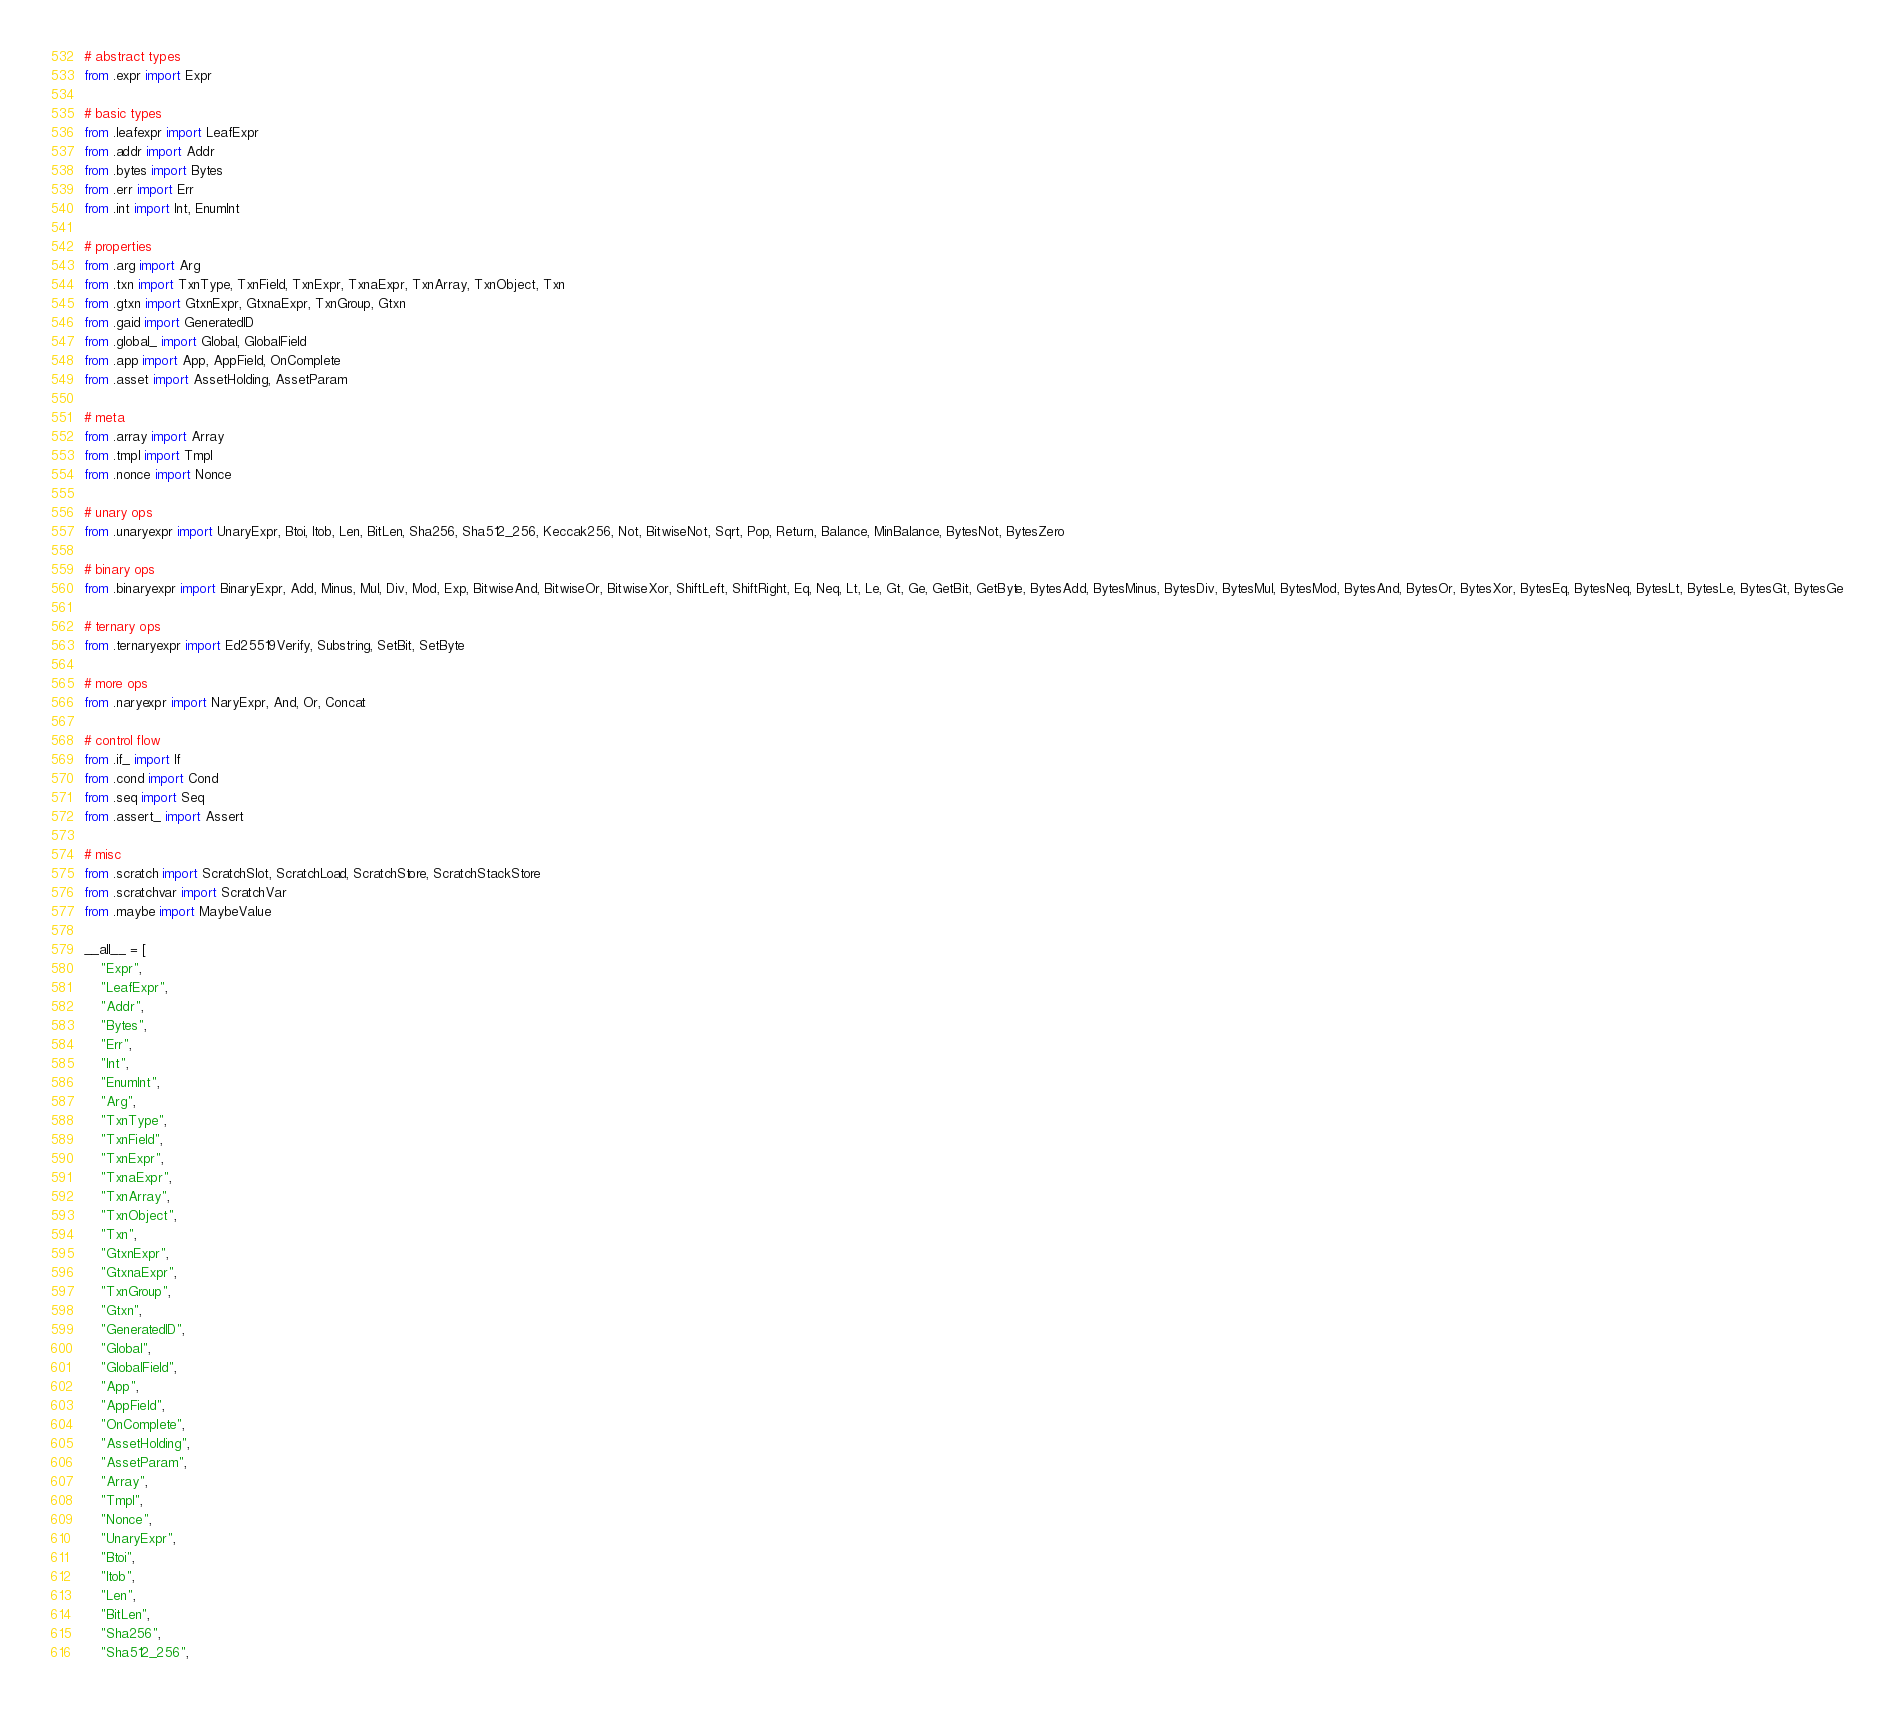Convert code to text. <code><loc_0><loc_0><loc_500><loc_500><_Python_># abstract types
from .expr import Expr

# basic types
from .leafexpr import LeafExpr
from .addr import Addr
from .bytes import Bytes
from .err import Err
from .int import Int, EnumInt

# properties
from .arg import Arg
from .txn import TxnType, TxnField, TxnExpr, TxnaExpr, TxnArray, TxnObject, Txn
from .gtxn import GtxnExpr, GtxnaExpr, TxnGroup, Gtxn
from .gaid import GeneratedID
from .global_ import Global, GlobalField
from .app import App, AppField, OnComplete
from .asset import AssetHolding, AssetParam

# meta
from .array import Array
from .tmpl import Tmpl
from .nonce import Nonce

# unary ops
from .unaryexpr import UnaryExpr, Btoi, Itob, Len, BitLen, Sha256, Sha512_256, Keccak256, Not, BitwiseNot, Sqrt, Pop, Return, Balance, MinBalance, BytesNot, BytesZero

# binary ops
from .binaryexpr import BinaryExpr, Add, Minus, Mul, Div, Mod, Exp, BitwiseAnd, BitwiseOr, BitwiseXor, ShiftLeft, ShiftRight, Eq, Neq, Lt, Le, Gt, Ge, GetBit, GetByte, BytesAdd, BytesMinus, BytesDiv, BytesMul, BytesMod, BytesAnd, BytesOr, BytesXor, BytesEq, BytesNeq, BytesLt, BytesLe, BytesGt, BytesGe

# ternary ops
from .ternaryexpr import Ed25519Verify, Substring, SetBit, SetByte

# more ops
from .naryexpr import NaryExpr, And, Or, Concat

# control flow
from .if_ import If
from .cond import Cond
from .seq import Seq
from .assert_ import Assert

# misc
from .scratch import ScratchSlot, ScratchLoad, ScratchStore, ScratchStackStore
from .scratchvar import ScratchVar
from .maybe import MaybeValue

__all__ = [
    "Expr",
    "LeafExpr",
    "Addr",
    "Bytes",
    "Err",
    "Int",
    "EnumInt",
    "Arg",
    "TxnType",
    "TxnField",
    "TxnExpr",
    "TxnaExpr",
    "TxnArray",
    "TxnObject",
    "Txn",
    "GtxnExpr",
    "GtxnaExpr",
    "TxnGroup",
    "Gtxn",
    "GeneratedID",
    "Global",
    "GlobalField",
    "App",
    "AppField",
    "OnComplete",
    "AssetHolding",
    "AssetParam",
    "Array",
    "Tmpl",
    "Nonce",
    "UnaryExpr",
    "Btoi",
    "Itob",
    "Len",
    "BitLen",
    "Sha256",
    "Sha512_256",</code> 